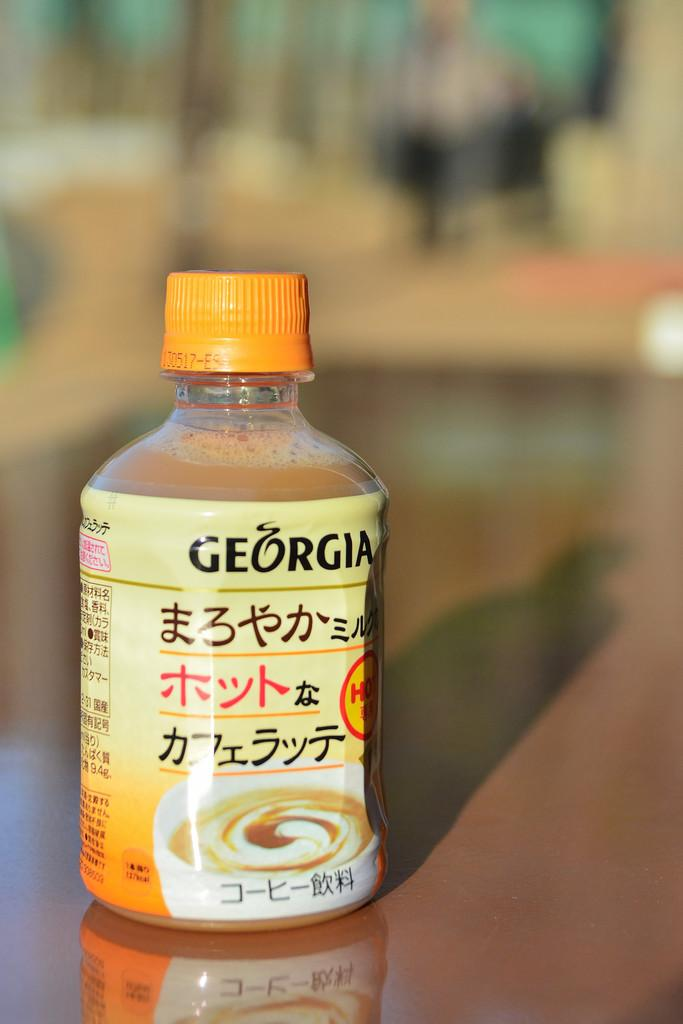<image>
Render a clear and concise summary of the photo. A bottle of Georgia creamer sits on top of an empty table 